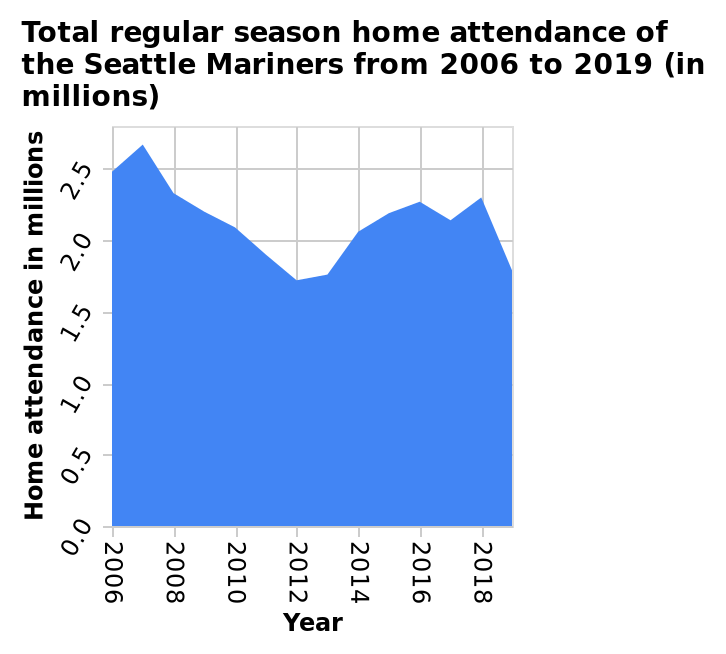<image>
What is the unit of measurement for the home attendance in the area plot?  The unit of measurement for the home attendance in the area plot is in millions. What is the reason for the lack of assistance? The reason for the lack of assistance is that the fans are either staying in to watch the game or in a bar. please enumerates aspects of the construction of the chart This is a area plot titled Total regular season home attendance of the Seattle Mariners from 2006 to 2019 (in millions). The x-axis plots Year using a linear scale from 2006 to 2018. Along the y-axis, Home attendance in millions is drawn. What is plotted on the x-axis of the area plot?  The x-axis of the area plot represents the years from 2006 to 2018 using a linear scale. 